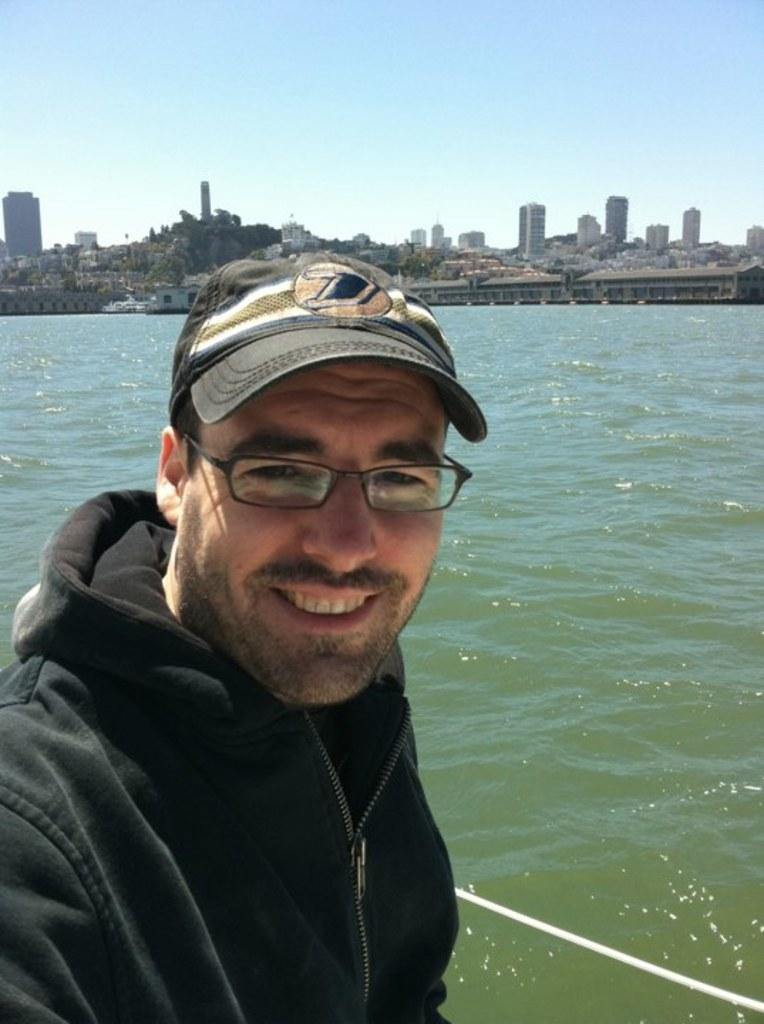What is the main subject in the foreground of the image? There is a person standing in the foreground of the image. What can be seen in the background of the image? There are buildings and water visible in the background of the image. What else is visible in the background of the image? The sky is also visible in the background of the image. How many rings are visible on the person's fingers in the image? There is no information about rings or the person's fingers in the provided facts, so we cannot determine the number of rings visible. 